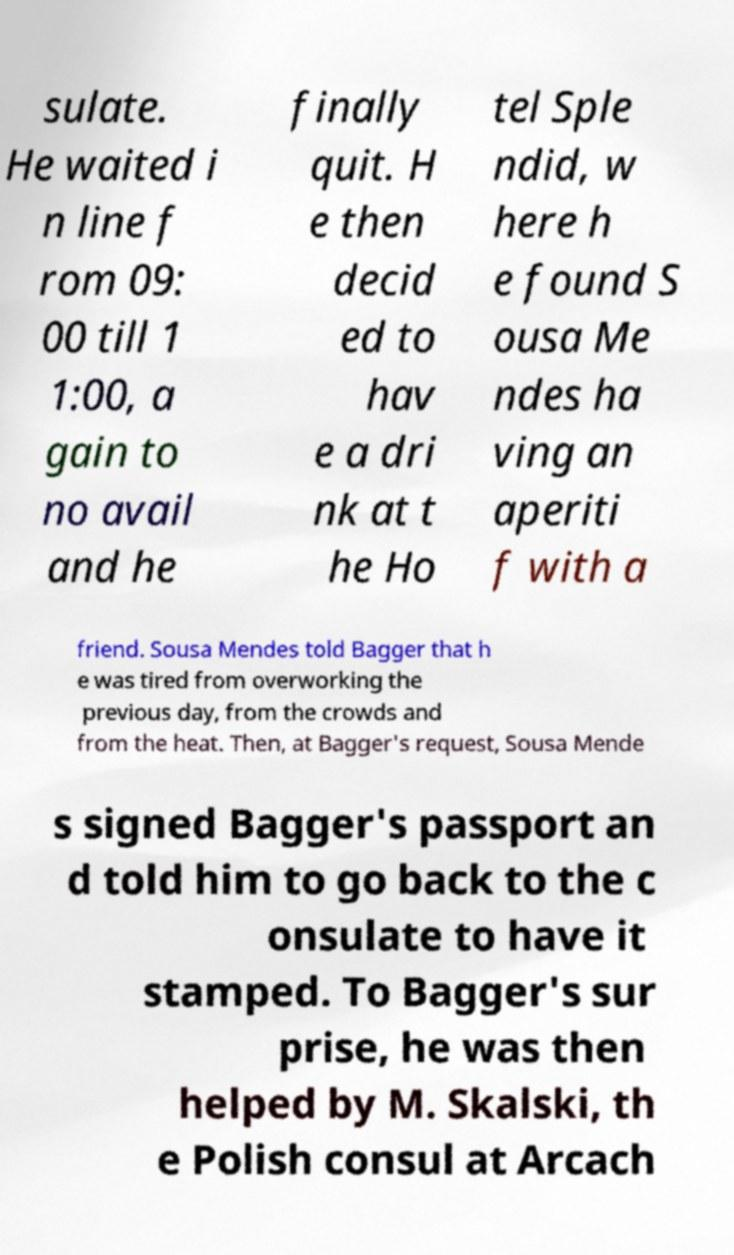There's text embedded in this image that I need extracted. Can you transcribe it verbatim? sulate. He waited i n line f rom 09: 00 till 1 1:00, a gain to no avail and he finally quit. H e then decid ed to hav e a dri nk at t he Ho tel Sple ndid, w here h e found S ousa Me ndes ha ving an aperiti f with a friend. Sousa Mendes told Bagger that h e was tired from overworking the previous day, from the crowds and from the heat. Then, at Bagger's request, Sousa Mende s signed Bagger's passport an d told him to go back to the c onsulate to have it stamped. To Bagger's sur prise, he was then helped by M. Skalski, th e Polish consul at Arcach 